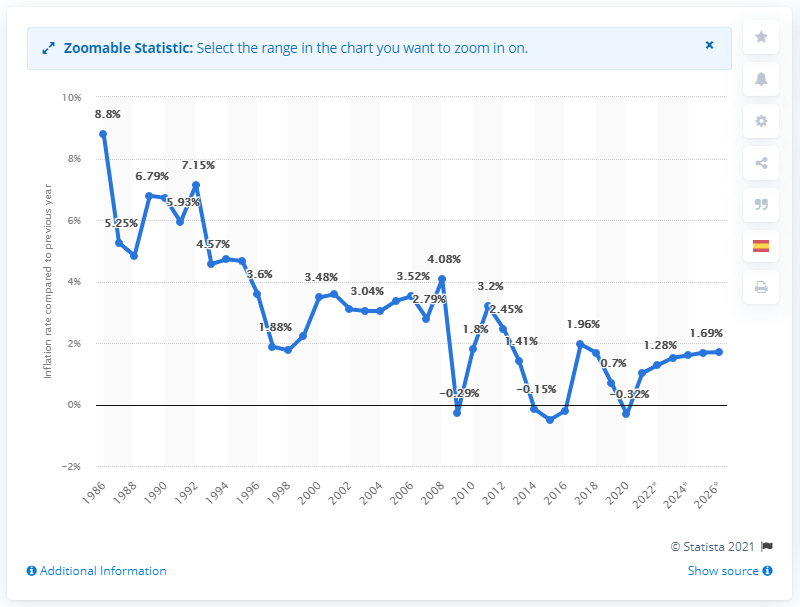Identify some key points in this picture. In 2019, the inflation rate in Spain was 0.7%. 